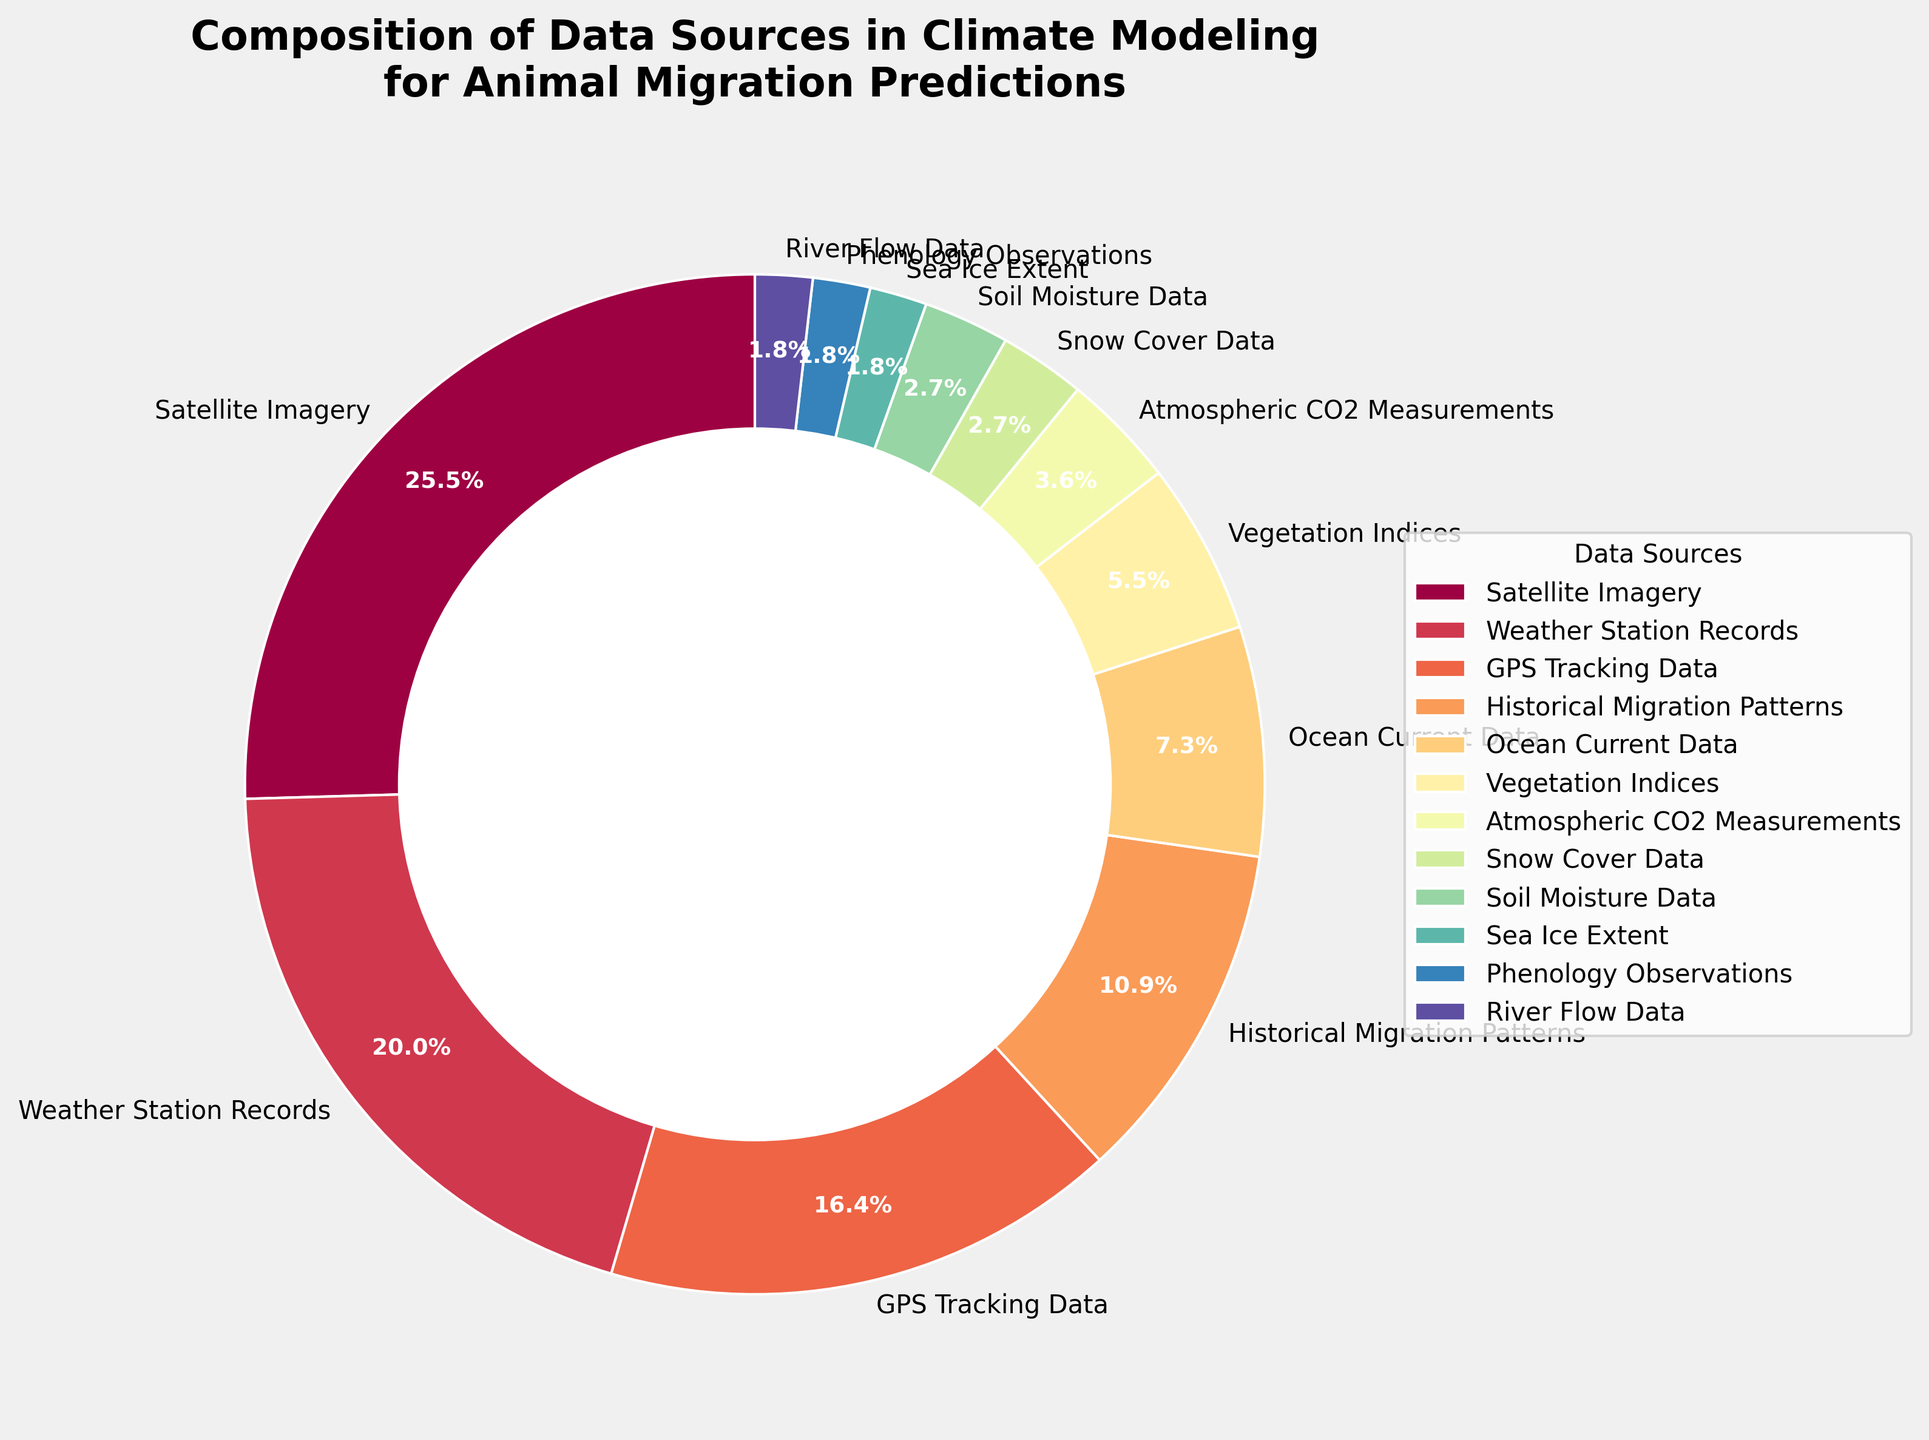How many data sources together contribute more than half of the total percentage? To answer this, find the cumulative percentage starting from the largest component until it exceeds 50%. Satellite Imagery (28%) + Weather Station Records (22%) = 50%. Thus, it takes 2 sources.
Answer: 2 Which two data sources contribute equally and what is their individual percentage? Identify the data sources with equal percentages by examining the pie chart. Snow Cover Data, Soil Moisture Data, River Flow Data, and Phenology Observations each contribute 2%.
Answer: 2% What's the percentage contribution of Vegetation Indices and Atmospheric CO2 Measurements combined? Summing up the percentages for Vegetation Indices (6%) and Atmospheric CO2 Measurements (4%) gives 6% + 4% = 10%.
Answer: 10% Compare the percentage of Sea Ice Extent and Ocean Current Data. Which is higher? Comparing the individual percentages, Ocean Current Data (8%) is higher than Sea Ice Extent (2%).
Answer: Ocean Current Data What's the total percentage of data sources contributing less than 5% each? Sum the percentages of each component contributing less than 5%: Atmospheric CO2 Measurements (4%) + Snow Cover Data (3%) + Soil Moisture Data (3%) + Sea Ice Extent (2%) + Phenology Observations (2%) + River Flow Data (2%) = 16%.
Answer: 16% Which data source has the second-largest contribution, and what is its percentage? By examining the pie chart, Weather Station Records is the second-largest contributor with 22%.
Answer: Weather Station Records, 22% What is the difference in percentage between the highest and lowest contributing data sources? Calculate the difference between Satellite Imagery (28%) and the lowest, which are Sea Ice Extent, Phenology Observations, and River Flow Data (each 2%) resulting in 28% - 2% = 26%.
Answer: 26% Considering data sources contributing greater than 10%, what is their total contribution? Sum the percentages of sources with greater than 10%: Satellite Imagery (28%) + Weather Station Records (22%) + GPS Tracking Data (18%) + Historical Migration Patterns (12%) = 80%.
Answer: 80% What proportion of the total does the combination of Ocean Current Data and Vegetation Indices represent? Sum their percentages: Ocean Current Data (8%) + Vegetation Indices (6%) resulting in 8% + 6% = 14%. Then, calculate the proportion: 14% / 100% = 0.14, which is 14%.
Answer: 14% Which data source uses **green** as its color according to the custom color palette? By closely examining the pie chart color assignments provided by the custom color palette, and considering this is a hypothetical question and visualization palette, the answer can't be definitively given here without visual inspection.
Answer: Hypothetical based on visual inspection 